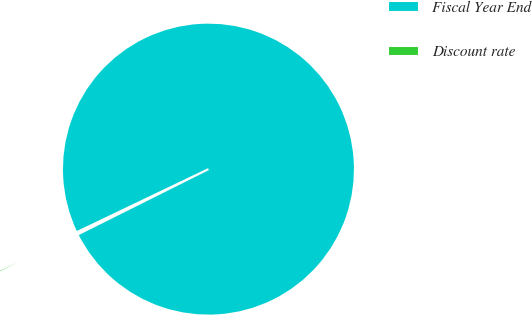<chart> <loc_0><loc_0><loc_500><loc_500><pie_chart><fcel>Fiscal Year End<fcel>Discount rate<nl><fcel>99.73%<fcel>0.27%<nl></chart> 